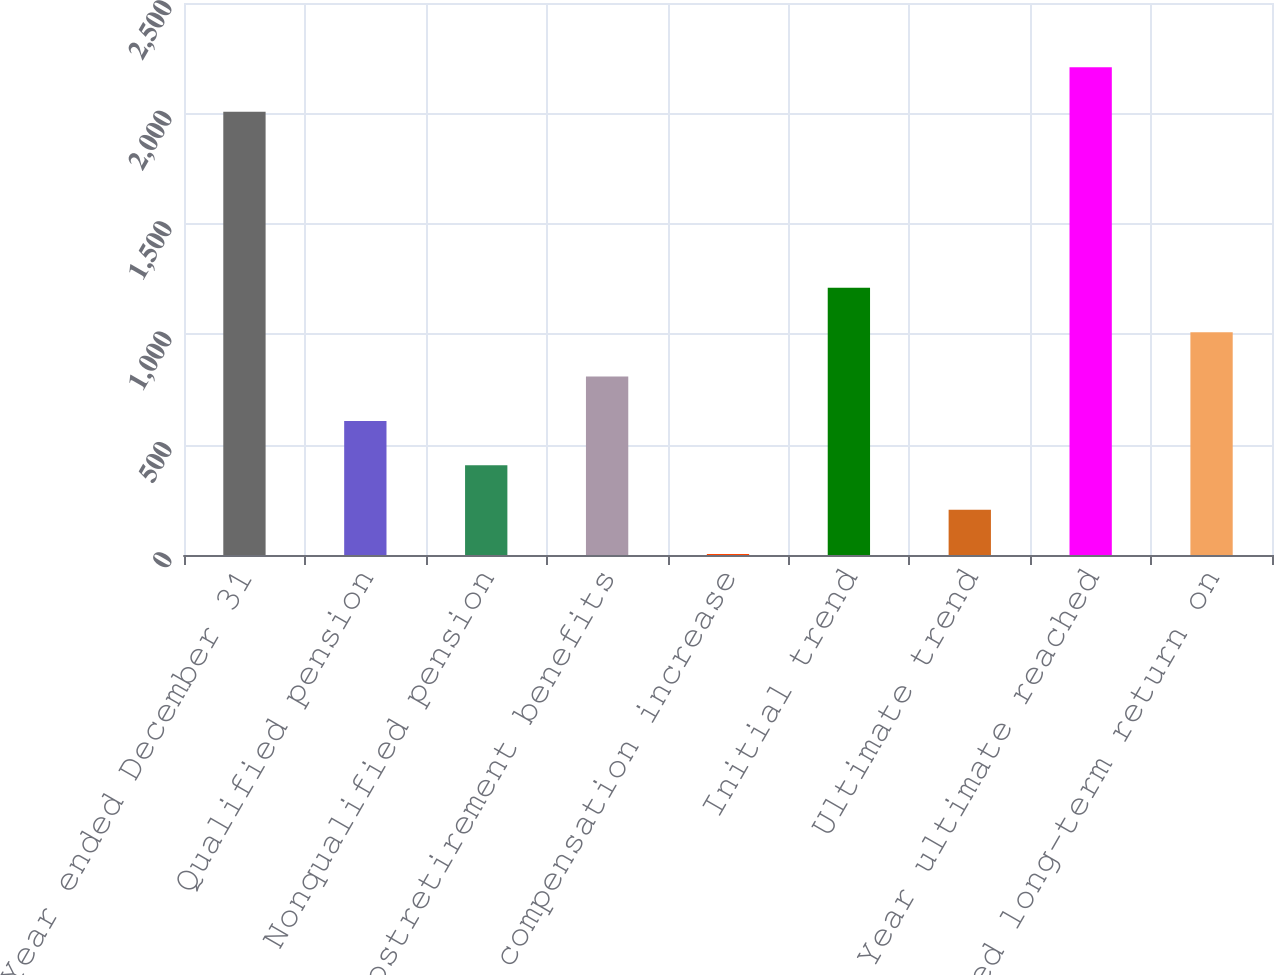<chart> <loc_0><loc_0><loc_500><loc_500><bar_chart><fcel>Year ended December 31<fcel>Qualified pension<fcel>Nonqualified pension<fcel>Postretirement benefits<fcel>Rate of compensation increase<fcel>Initial trend<fcel>Ultimate trend<fcel>Year ultimate reached<fcel>Expected long-term return on<nl><fcel>2008<fcel>607<fcel>406<fcel>808<fcel>4<fcel>1210<fcel>205<fcel>2209<fcel>1009<nl></chart> 